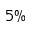<formula> <loc_0><loc_0><loc_500><loc_500>5 \%</formula> 